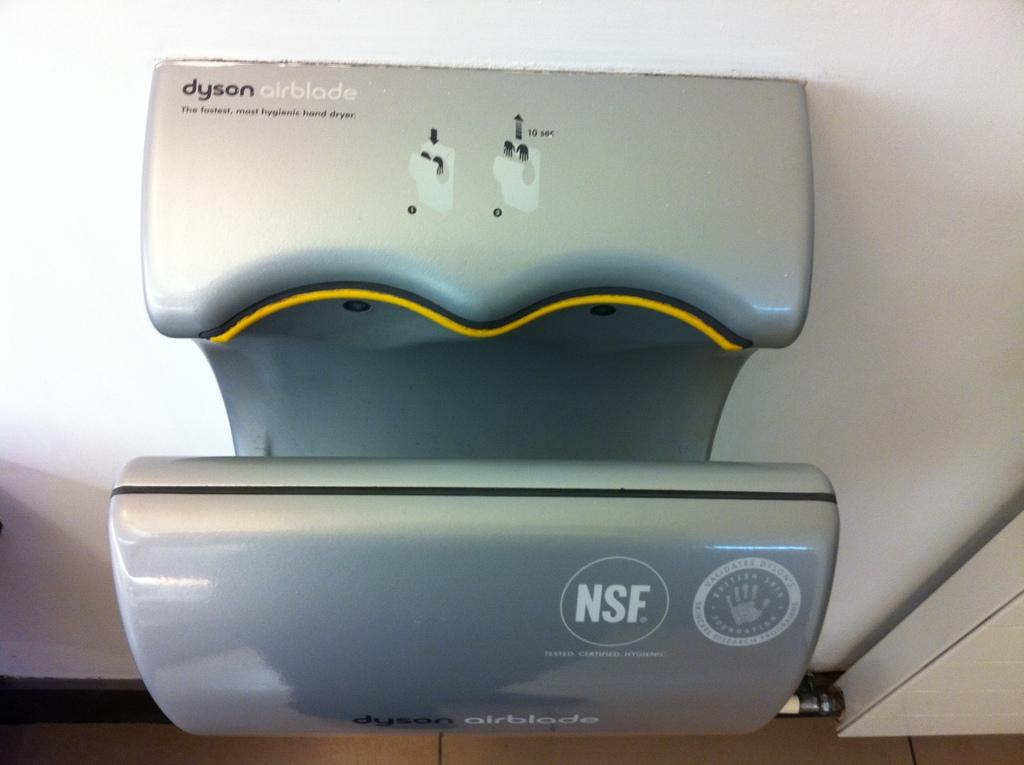What is the color of the wall in the image? The wall in the image is white. What type of object can be seen in the image? There is an electrical equipment in the image. What type of key is used to unlock the electrical equipment in the image? There is no key present in the image, and the electrical equipment is not shown to be locked. 